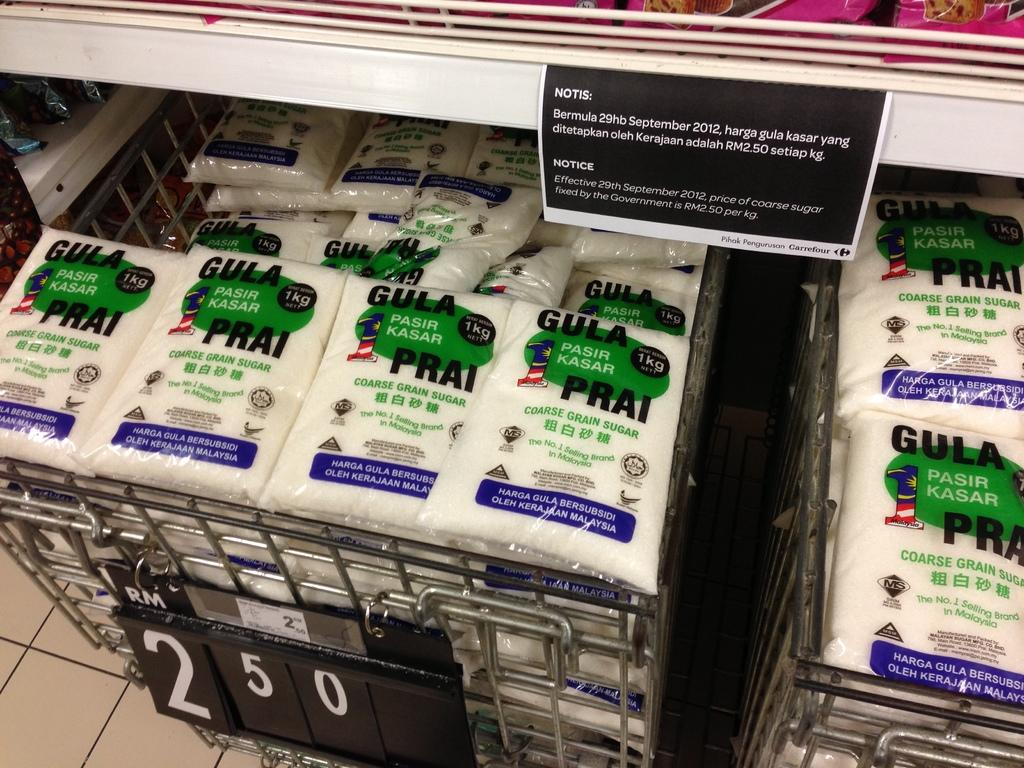<image>
Provide a brief description of the given image. Gula Prai products fill a display with 2.50 marked as the price. 